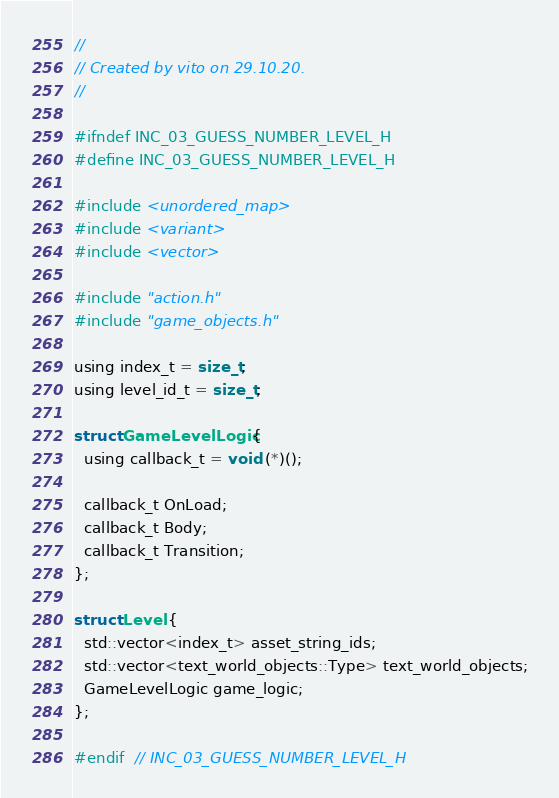<code> <loc_0><loc_0><loc_500><loc_500><_C_>//
// Created by vito on 29.10.20.
//

#ifndef INC_03_GUESS_NUMBER_LEVEL_H
#define INC_03_GUESS_NUMBER_LEVEL_H

#include <unordered_map>
#include <variant>
#include <vector>

#include "action.h"
#include "game_objects.h"

using index_t = size_t;
using level_id_t = size_t;

struct GameLevelLogic {
  using callback_t = void (*)();

  callback_t OnLoad;
  callback_t Body;
  callback_t Transition;
};

struct Level {
  std::vector<index_t> asset_string_ids;
  std::vector<text_world_objects::Type> text_world_objects;
  GameLevelLogic game_logic;
};

#endif  // INC_03_GUESS_NUMBER_LEVEL_H
</code> 